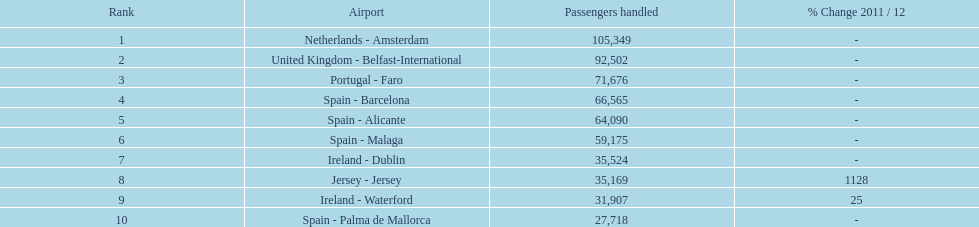What is the total number of airports mentioned? 10. 